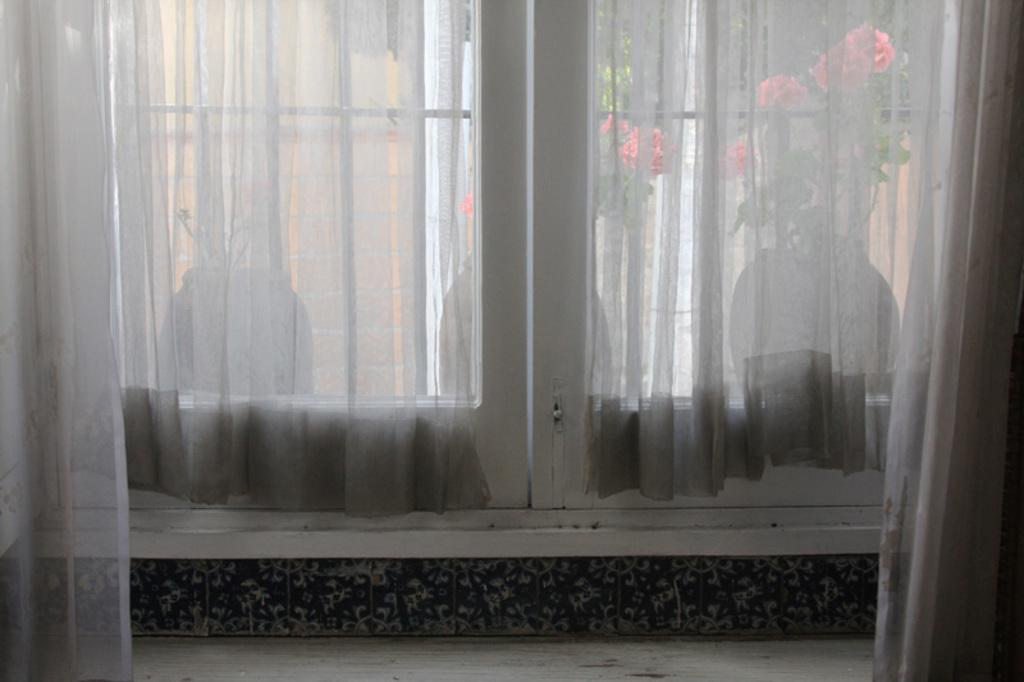What type of window treatment is present in the image? There are curtains in the image. What is located near the curtains? There is a window in the image. What can be seen through the window? Plants with pots and flowers are visible through the window. What type of crate is visible in the image? There is no crate present in the image. How does the fork contribute to the value of the image? There is no fork present in the image, so it cannot contribute to the value. 